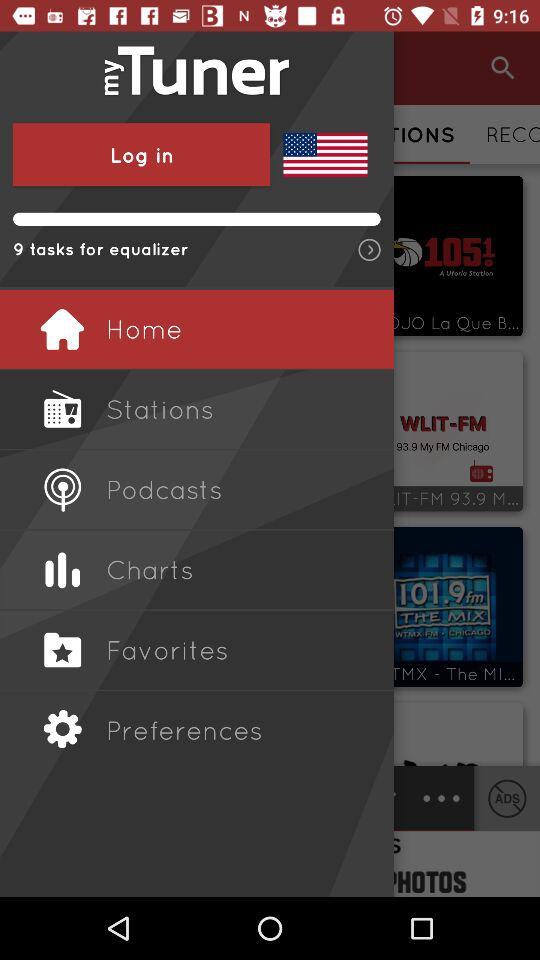How many tasks are for the equalizer? The tasks for the equalizer are 9. 